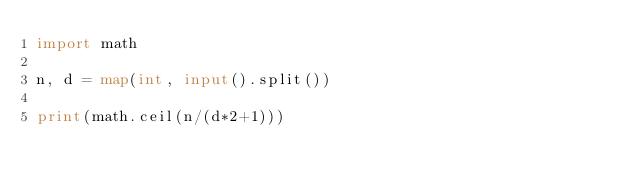Convert code to text. <code><loc_0><loc_0><loc_500><loc_500><_Python_>import math

n, d = map(int, input().split())

print(math.ceil(n/(d*2+1)))
</code> 